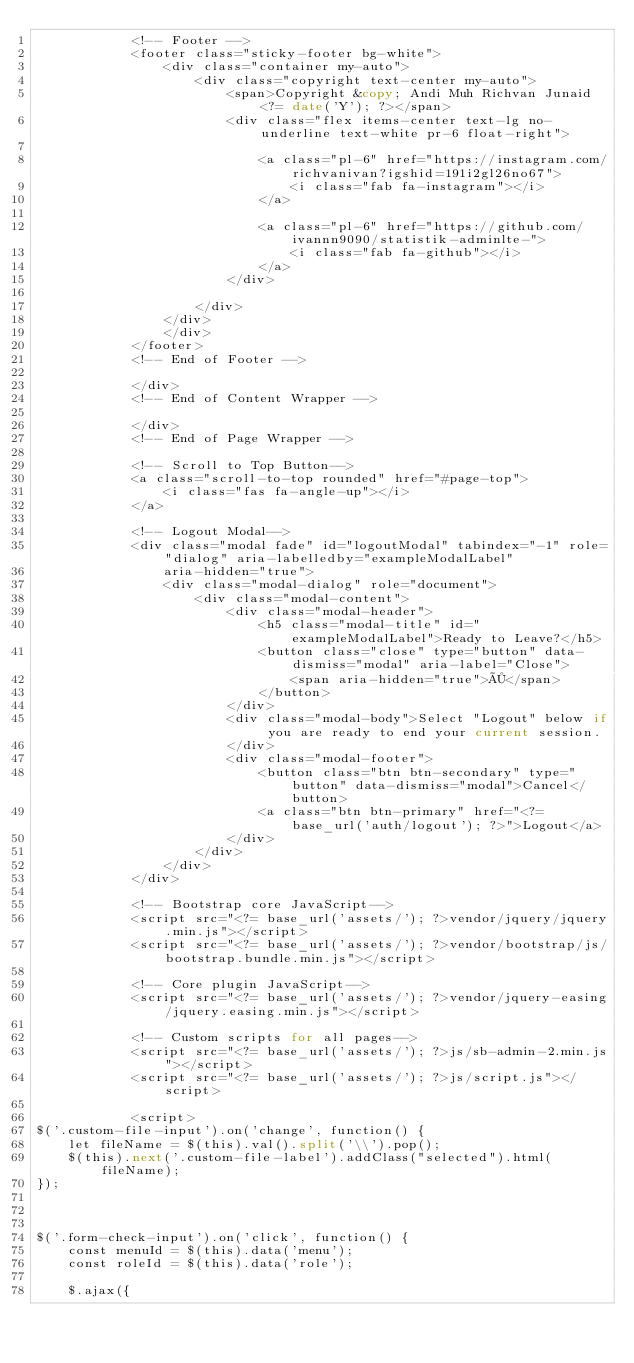Convert code to text. <code><loc_0><loc_0><loc_500><loc_500><_PHP_>            <!-- Footer -->
            <footer class="sticky-footer bg-white">
                <div class="container my-auto">
                    <div class="copyright text-center my-auto">
                        <span>Copyright &copy; Andi Muh Richvan Junaid <?= date('Y'); ?></span>
                        <div class="flex items-center text-lg no-underline text-white pr-6 float-right">

                            <a class="pl-6" href="https://instagram.com/richvanivan?igshid=191i2gl26no67">
                                <i class="fab fa-instagram"></i>
                            </a>

                            <a class="pl-6" href="https://github.com/ivannn9090/statistik-adminlte-">
                                <i class="fab fa-github"></i>
                            </a>
                        </div>

                    </div>
                </div>
                </div>
            </footer>
            <!-- End of Footer -->

            </div>
            <!-- End of Content Wrapper -->

            </div>
            <!-- End of Page Wrapper -->

            <!-- Scroll to Top Button-->
            <a class="scroll-to-top rounded" href="#page-top">
                <i class="fas fa-angle-up"></i>
            </a>

            <!-- Logout Modal-->
            <div class="modal fade" id="logoutModal" tabindex="-1" role="dialog" aria-labelledby="exampleModalLabel"
                aria-hidden="true">
                <div class="modal-dialog" role="document">
                    <div class="modal-content">
                        <div class="modal-header">
                            <h5 class="modal-title" id="exampleModalLabel">Ready to Leave?</h5>
                            <button class="close" type="button" data-dismiss="modal" aria-label="Close">
                                <span aria-hidden="true">×</span>
                            </button>
                        </div>
                        <div class="modal-body">Select "Logout" below if you are ready to end your current session.
                        </div>
                        <div class="modal-footer">
                            <button class="btn btn-secondary" type="button" data-dismiss="modal">Cancel</button>
                            <a class="btn btn-primary" href="<?= base_url('auth/logout'); ?>">Logout</a>
                        </div>
                    </div>
                </div>
            </div>

            <!-- Bootstrap core JavaScript-->
            <script src="<?= base_url('assets/'); ?>vendor/jquery/jquery.min.js"></script>
            <script src="<?= base_url('assets/'); ?>vendor/bootstrap/js/bootstrap.bundle.min.js"></script>

            <!-- Core plugin JavaScript-->
            <script src="<?= base_url('assets/'); ?>vendor/jquery-easing/jquery.easing.min.js"></script>

            <!-- Custom scripts for all pages-->
            <script src="<?= base_url('assets/'); ?>js/sb-admin-2.min.js"></script>
            <script src="<?= base_url('assets/'); ?>js/script.js"></script>

            <script>
$('.custom-file-input').on('change', function() {
    let fileName = $(this).val().split('\\').pop();
    $(this).next('.custom-file-label').addClass("selected").html(fileName);
});



$('.form-check-input').on('click', function() {
    const menuId = $(this).data('menu');
    const roleId = $(this).data('role');

    $.ajax({</code> 